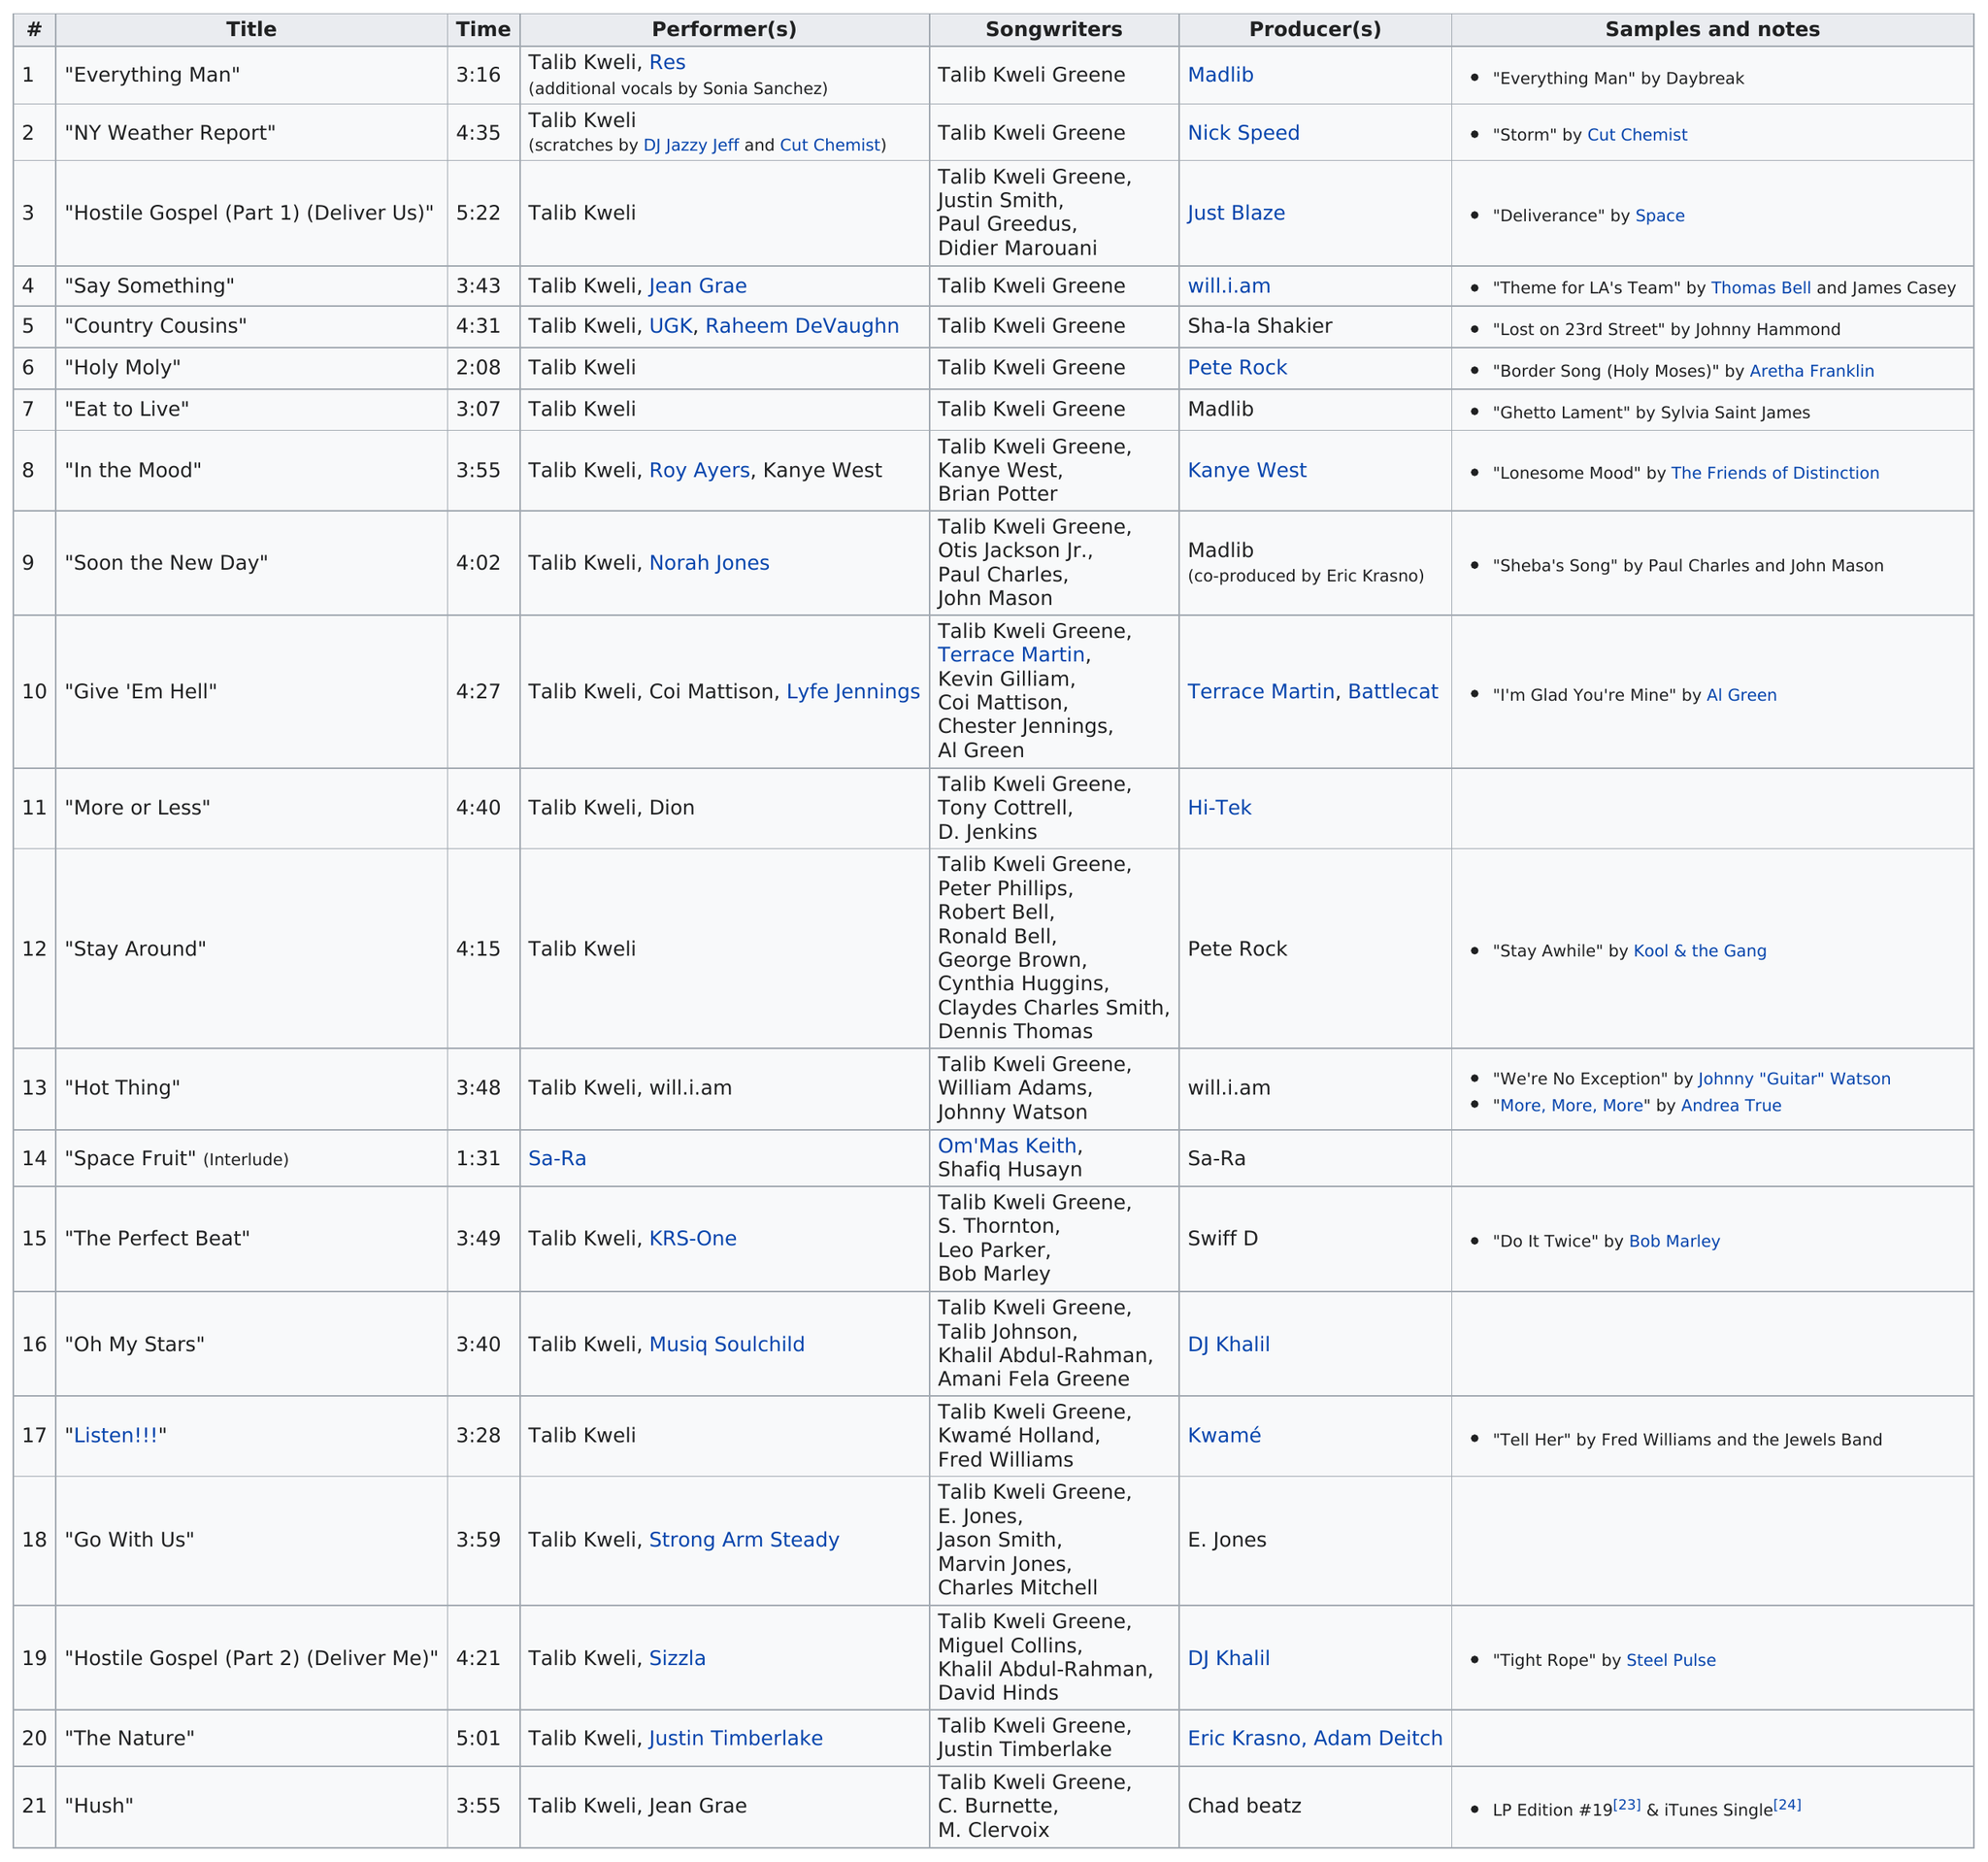List a handful of essential elements in this visual. I hereby declare that 'NY Weather Report' is longer than 'Country Cousins'. The track that comes after "Say Something" is "Country Cousins". The previous song to "Hot Thing" was "Stay Around. The first track listed on the album is titled 'Everything Man' Hostile Gospel (Part 1) (Deliver Us) had the longest run time among all titles. 